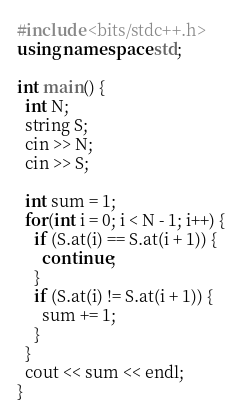Convert code to text. <code><loc_0><loc_0><loc_500><loc_500><_C++_>#include <bits/stdc++.h>
using namespace std;

int main() {
  int N;
  string S;
  cin >> N;
  cin >> S;
  
  int sum = 1;
  for(int i = 0; i < N - 1; i++) {
    if (S.at(i) == S.at(i + 1)) {
      continue;
    }
    if (S.at(i) != S.at(i + 1)) {
      sum += 1;
    }
  }
  cout << sum << endl;
}</code> 